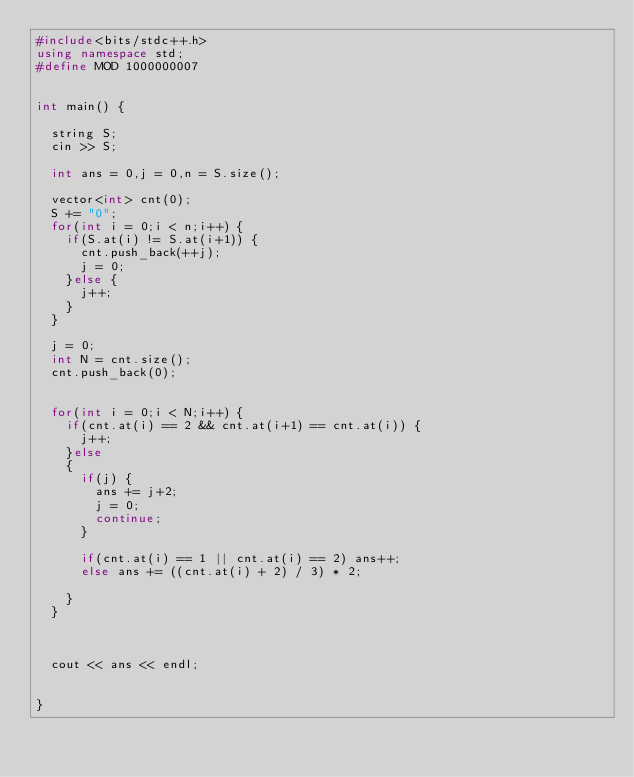<code> <loc_0><loc_0><loc_500><loc_500><_C++_>#include<bits/stdc++.h>
using namespace std;
#define MOD 1000000007


int main() {
  
  string S;
  cin >> S;

  int ans = 0,j = 0,n = S.size();
  
  vector<int> cnt(0);
  S += "0";
  for(int i = 0;i < n;i++) {
    if(S.at(i) != S.at(i+1)) {
      cnt.push_back(++j);
      j = 0;
    }else {
      j++;
    }
  } 

  j = 0;
  int N = cnt.size();
  cnt.push_back(0);
  

  for(int i = 0;i < N;i++) {
    if(cnt.at(i) == 2 && cnt.at(i+1) == cnt.at(i)) {
      j++;
    }else 
    {
      if(j) {
        ans += j+2;
        j = 0;
        continue;
      }

      if(cnt.at(i) == 1 || cnt.at(i) == 2) ans++;
      else ans += ((cnt.at(i) + 2) / 3) * 2;
      
    }
  }

  

  cout << ans << endl;
  
  
}</code> 